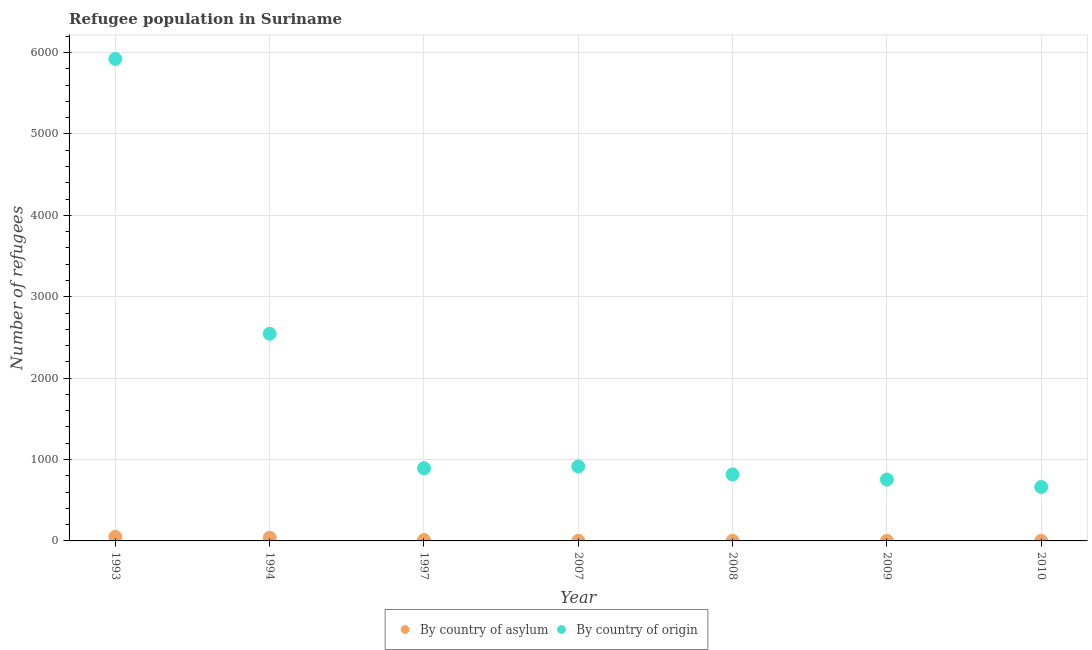Is the number of dotlines equal to the number of legend labels?
Offer a terse response. Yes. What is the number of refugees by country of origin in 1994?
Your response must be concise. 2545. Across all years, what is the maximum number of refugees by country of origin?
Provide a short and direct response. 5921. Across all years, what is the minimum number of refugees by country of asylum?
Offer a very short reply. 1. What is the total number of refugees by country of origin in the graph?
Your response must be concise. 1.25e+04. What is the difference between the number of refugees by country of origin in 1993 and that in 2010?
Make the answer very short. 5258. What is the difference between the number of refugees by country of asylum in 1994 and the number of refugees by country of origin in 2008?
Your answer should be very brief. -778. What is the average number of refugees by country of origin per year?
Your answer should be very brief. 1786.86. In the year 1993, what is the difference between the number of refugees by country of asylum and number of refugees by country of origin?
Your answer should be compact. -5871. In how many years, is the number of refugees by country of asylum greater than 1000?
Make the answer very short. 0. What is the ratio of the number of refugees by country of origin in 2008 to that in 2009?
Your response must be concise. 1.08. Is the number of refugees by country of origin in 1997 less than that in 2009?
Provide a succinct answer. No. What is the difference between the highest and the second highest number of refugees by country of origin?
Offer a terse response. 3376. What is the difference between the highest and the lowest number of refugees by country of asylum?
Make the answer very short. 49. In how many years, is the number of refugees by country of origin greater than the average number of refugees by country of origin taken over all years?
Your response must be concise. 2. Is the sum of the number of refugees by country of asylum in 1997 and 2010 greater than the maximum number of refugees by country of origin across all years?
Ensure brevity in your answer.  No. Does the number of refugees by country of origin monotonically increase over the years?
Your response must be concise. No. Is the number of refugees by country of asylum strictly greater than the number of refugees by country of origin over the years?
Provide a succinct answer. No. How many dotlines are there?
Keep it short and to the point. 2. Are the values on the major ticks of Y-axis written in scientific E-notation?
Offer a very short reply. No. Does the graph contain any zero values?
Make the answer very short. No. Does the graph contain grids?
Ensure brevity in your answer.  Yes. Where does the legend appear in the graph?
Your answer should be compact. Bottom center. What is the title of the graph?
Keep it short and to the point. Refugee population in Suriname. Does "Merchandise imports" appear as one of the legend labels in the graph?
Give a very brief answer. No. What is the label or title of the X-axis?
Provide a short and direct response. Year. What is the label or title of the Y-axis?
Ensure brevity in your answer.  Number of refugees. What is the Number of refugees of By country of origin in 1993?
Make the answer very short. 5921. What is the Number of refugees in By country of asylum in 1994?
Ensure brevity in your answer.  39. What is the Number of refugees of By country of origin in 1994?
Keep it short and to the point. 2545. What is the Number of refugees in By country of asylum in 1997?
Offer a terse response. 11. What is the Number of refugees of By country of origin in 1997?
Keep it short and to the point. 893. What is the Number of refugees in By country of asylum in 2007?
Make the answer very short. 1. What is the Number of refugees in By country of origin in 2007?
Make the answer very short. 915. What is the Number of refugees of By country of asylum in 2008?
Ensure brevity in your answer.  1. What is the Number of refugees of By country of origin in 2008?
Make the answer very short. 817. What is the Number of refugees in By country of asylum in 2009?
Make the answer very short. 1. What is the Number of refugees of By country of origin in 2009?
Provide a short and direct response. 754. What is the Number of refugees of By country of origin in 2010?
Keep it short and to the point. 663. Across all years, what is the maximum Number of refugees in By country of origin?
Your answer should be very brief. 5921. Across all years, what is the minimum Number of refugees of By country of origin?
Keep it short and to the point. 663. What is the total Number of refugees of By country of asylum in the graph?
Give a very brief answer. 104. What is the total Number of refugees in By country of origin in the graph?
Provide a short and direct response. 1.25e+04. What is the difference between the Number of refugees of By country of asylum in 1993 and that in 1994?
Provide a short and direct response. 11. What is the difference between the Number of refugees in By country of origin in 1993 and that in 1994?
Make the answer very short. 3376. What is the difference between the Number of refugees in By country of asylum in 1993 and that in 1997?
Your answer should be very brief. 39. What is the difference between the Number of refugees in By country of origin in 1993 and that in 1997?
Offer a terse response. 5028. What is the difference between the Number of refugees in By country of origin in 1993 and that in 2007?
Provide a short and direct response. 5006. What is the difference between the Number of refugees of By country of asylum in 1993 and that in 2008?
Your response must be concise. 49. What is the difference between the Number of refugees in By country of origin in 1993 and that in 2008?
Your answer should be very brief. 5104. What is the difference between the Number of refugees in By country of origin in 1993 and that in 2009?
Keep it short and to the point. 5167. What is the difference between the Number of refugees of By country of origin in 1993 and that in 2010?
Ensure brevity in your answer.  5258. What is the difference between the Number of refugees in By country of asylum in 1994 and that in 1997?
Ensure brevity in your answer.  28. What is the difference between the Number of refugees of By country of origin in 1994 and that in 1997?
Offer a very short reply. 1652. What is the difference between the Number of refugees of By country of asylum in 1994 and that in 2007?
Your answer should be very brief. 38. What is the difference between the Number of refugees in By country of origin in 1994 and that in 2007?
Your answer should be very brief. 1630. What is the difference between the Number of refugees of By country of origin in 1994 and that in 2008?
Offer a terse response. 1728. What is the difference between the Number of refugees of By country of asylum in 1994 and that in 2009?
Give a very brief answer. 38. What is the difference between the Number of refugees in By country of origin in 1994 and that in 2009?
Your response must be concise. 1791. What is the difference between the Number of refugees in By country of asylum in 1994 and that in 2010?
Your answer should be very brief. 38. What is the difference between the Number of refugees in By country of origin in 1994 and that in 2010?
Provide a succinct answer. 1882. What is the difference between the Number of refugees in By country of asylum in 1997 and that in 2007?
Make the answer very short. 10. What is the difference between the Number of refugees in By country of asylum in 1997 and that in 2008?
Make the answer very short. 10. What is the difference between the Number of refugees of By country of origin in 1997 and that in 2008?
Your answer should be very brief. 76. What is the difference between the Number of refugees in By country of origin in 1997 and that in 2009?
Offer a very short reply. 139. What is the difference between the Number of refugees of By country of origin in 1997 and that in 2010?
Your response must be concise. 230. What is the difference between the Number of refugees in By country of asylum in 2007 and that in 2008?
Offer a terse response. 0. What is the difference between the Number of refugees of By country of origin in 2007 and that in 2008?
Your response must be concise. 98. What is the difference between the Number of refugees in By country of asylum in 2007 and that in 2009?
Provide a succinct answer. 0. What is the difference between the Number of refugees of By country of origin in 2007 and that in 2009?
Ensure brevity in your answer.  161. What is the difference between the Number of refugees of By country of asylum in 2007 and that in 2010?
Provide a succinct answer. 0. What is the difference between the Number of refugees in By country of origin in 2007 and that in 2010?
Your answer should be very brief. 252. What is the difference between the Number of refugees of By country of asylum in 2008 and that in 2009?
Your answer should be compact. 0. What is the difference between the Number of refugees of By country of asylum in 2008 and that in 2010?
Make the answer very short. 0. What is the difference between the Number of refugees of By country of origin in 2008 and that in 2010?
Ensure brevity in your answer.  154. What is the difference between the Number of refugees in By country of asylum in 2009 and that in 2010?
Your response must be concise. 0. What is the difference between the Number of refugees of By country of origin in 2009 and that in 2010?
Your answer should be compact. 91. What is the difference between the Number of refugees in By country of asylum in 1993 and the Number of refugees in By country of origin in 1994?
Make the answer very short. -2495. What is the difference between the Number of refugees in By country of asylum in 1993 and the Number of refugees in By country of origin in 1997?
Provide a succinct answer. -843. What is the difference between the Number of refugees of By country of asylum in 1993 and the Number of refugees of By country of origin in 2007?
Your answer should be very brief. -865. What is the difference between the Number of refugees in By country of asylum in 1993 and the Number of refugees in By country of origin in 2008?
Give a very brief answer. -767. What is the difference between the Number of refugees in By country of asylum in 1993 and the Number of refugees in By country of origin in 2009?
Make the answer very short. -704. What is the difference between the Number of refugees of By country of asylum in 1993 and the Number of refugees of By country of origin in 2010?
Make the answer very short. -613. What is the difference between the Number of refugees of By country of asylum in 1994 and the Number of refugees of By country of origin in 1997?
Provide a succinct answer. -854. What is the difference between the Number of refugees of By country of asylum in 1994 and the Number of refugees of By country of origin in 2007?
Your answer should be compact. -876. What is the difference between the Number of refugees of By country of asylum in 1994 and the Number of refugees of By country of origin in 2008?
Ensure brevity in your answer.  -778. What is the difference between the Number of refugees of By country of asylum in 1994 and the Number of refugees of By country of origin in 2009?
Your answer should be compact. -715. What is the difference between the Number of refugees in By country of asylum in 1994 and the Number of refugees in By country of origin in 2010?
Ensure brevity in your answer.  -624. What is the difference between the Number of refugees of By country of asylum in 1997 and the Number of refugees of By country of origin in 2007?
Offer a very short reply. -904. What is the difference between the Number of refugees of By country of asylum in 1997 and the Number of refugees of By country of origin in 2008?
Keep it short and to the point. -806. What is the difference between the Number of refugees in By country of asylum in 1997 and the Number of refugees in By country of origin in 2009?
Offer a terse response. -743. What is the difference between the Number of refugees in By country of asylum in 1997 and the Number of refugees in By country of origin in 2010?
Offer a terse response. -652. What is the difference between the Number of refugees in By country of asylum in 2007 and the Number of refugees in By country of origin in 2008?
Your answer should be compact. -816. What is the difference between the Number of refugees in By country of asylum in 2007 and the Number of refugees in By country of origin in 2009?
Give a very brief answer. -753. What is the difference between the Number of refugees in By country of asylum in 2007 and the Number of refugees in By country of origin in 2010?
Your answer should be compact. -662. What is the difference between the Number of refugees of By country of asylum in 2008 and the Number of refugees of By country of origin in 2009?
Ensure brevity in your answer.  -753. What is the difference between the Number of refugees in By country of asylum in 2008 and the Number of refugees in By country of origin in 2010?
Ensure brevity in your answer.  -662. What is the difference between the Number of refugees in By country of asylum in 2009 and the Number of refugees in By country of origin in 2010?
Provide a succinct answer. -662. What is the average Number of refugees of By country of asylum per year?
Your answer should be compact. 14.86. What is the average Number of refugees of By country of origin per year?
Your answer should be very brief. 1786.86. In the year 1993, what is the difference between the Number of refugees in By country of asylum and Number of refugees in By country of origin?
Give a very brief answer. -5871. In the year 1994, what is the difference between the Number of refugees of By country of asylum and Number of refugees of By country of origin?
Offer a very short reply. -2506. In the year 1997, what is the difference between the Number of refugees in By country of asylum and Number of refugees in By country of origin?
Offer a very short reply. -882. In the year 2007, what is the difference between the Number of refugees of By country of asylum and Number of refugees of By country of origin?
Your response must be concise. -914. In the year 2008, what is the difference between the Number of refugees in By country of asylum and Number of refugees in By country of origin?
Provide a short and direct response. -816. In the year 2009, what is the difference between the Number of refugees of By country of asylum and Number of refugees of By country of origin?
Provide a short and direct response. -753. In the year 2010, what is the difference between the Number of refugees in By country of asylum and Number of refugees in By country of origin?
Give a very brief answer. -662. What is the ratio of the Number of refugees of By country of asylum in 1993 to that in 1994?
Your answer should be compact. 1.28. What is the ratio of the Number of refugees of By country of origin in 1993 to that in 1994?
Your response must be concise. 2.33. What is the ratio of the Number of refugees of By country of asylum in 1993 to that in 1997?
Your answer should be compact. 4.55. What is the ratio of the Number of refugees of By country of origin in 1993 to that in 1997?
Offer a terse response. 6.63. What is the ratio of the Number of refugees of By country of origin in 1993 to that in 2007?
Make the answer very short. 6.47. What is the ratio of the Number of refugees of By country of origin in 1993 to that in 2008?
Your response must be concise. 7.25. What is the ratio of the Number of refugees of By country of origin in 1993 to that in 2009?
Give a very brief answer. 7.85. What is the ratio of the Number of refugees in By country of asylum in 1993 to that in 2010?
Your answer should be very brief. 50. What is the ratio of the Number of refugees of By country of origin in 1993 to that in 2010?
Your answer should be very brief. 8.93. What is the ratio of the Number of refugees of By country of asylum in 1994 to that in 1997?
Give a very brief answer. 3.55. What is the ratio of the Number of refugees of By country of origin in 1994 to that in 1997?
Give a very brief answer. 2.85. What is the ratio of the Number of refugees of By country of asylum in 1994 to that in 2007?
Your answer should be very brief. 39. What is the ratio of the Number of refugees of By country of origin in 1994 to that in 2007?
Offer a terse response. 2.78. What is the ratio of the Number of refugees in By country of origin in 1994 to that in 2008?
Keep it short and to the point. 3.12. What is the ratio of the Number of refugees in By country of origin in 1994 to that in 2009?
Provide a short and direct response. 3.38. What is the ratio of the Number of refugees of By country of origin in 1994 to that in 2010?
Give a very brief answer. 3.84. What is the ratio of the Number of refugees of By country of origin in 1997 to that in 2007?
Offer a terse response. 0.98. What is the ratio of the Number of refugees in By country of origin in 1997 to that in 2008?
Provide a short and direct response. 1.09. What is the ratio of the Number of refugees in By country of asylum in 1997 to that in 2009?
Provide a succinct answer. 11. What is the ratio of the Number of refugees in By country of origin in 1997 to that in 2009?
Make the answer very short. 1.18. What is the ratio of the Number of refugees in By country of origin in 1997 to that in 2010?
Make the answer very short. 1.35. What is the ratio of the Number of refugees of By country of asylum in 2007 to that in 2008?
Ensure brevity in your answer.  1. What is the ratio of the Number of refugees in By country of origin in 2007 to that in 2008?
Provide a short and direct response. 1.12. What is the ratio of the Number of refugees of By country of asylum in 2007 to that in 2009?
Keep it short and to the point. 1. What is the ratio of the Number of refugees of By country of origin in 2007 to that in 2009?
Your answer should be very brief. 1.21. What is the ratio of the Number of refugees of By country of asylum in 2007 to that in 2010?
Offer a very short reply. 1. What is the ratio of the Number of refugees in By country of origin in 2007 to that in 2010?
Keep it short and to the point. 1.38. What is the ratio of the Number of refugees in By country of origin in 2008 to that in 2009?
Give a very brief answer. 1.08. What is the ratio of the Number of refugees of By country of asylum in 2008 to that in 2010?
Make the answer very short. 1. What is the ratio of the Number of refugees in By country of origin in 2008 to that in 2010?
Your answer should be very brief. 1.23. What is the ratio of the Number of refugees of By country of origin in 2009 to that in 2010?
Offer a terse response. 1.14. What is the difference between the highest and the second highest Number of refugees of By country of origin?
Your response must be concise. 3376. What is the difference between the highest and the lowest Number of refugees in By country of asylum?
Make the answer very short. 49. What is the difference between the highest and the lowest Number of refugees of By country of origin?
Your response must be concise. 5258. 